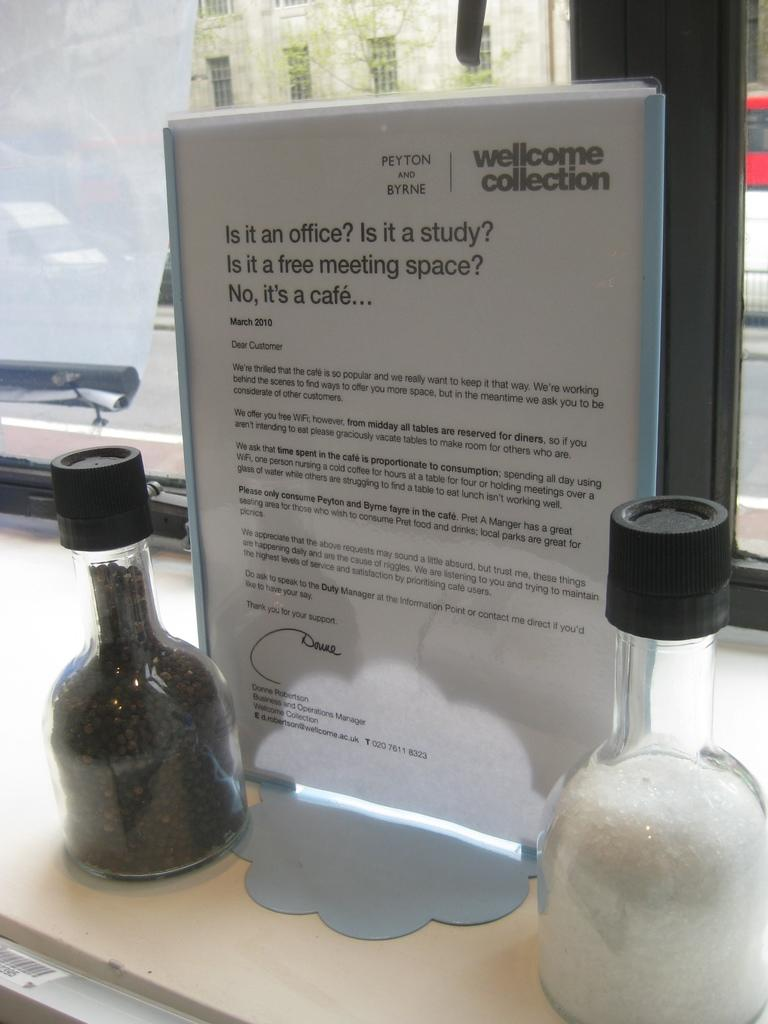<image>
Share a concise interpretation of the image provided. the word welcome is on the white piece of paper 